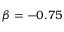<formula> <loc_0><loc_0><loc_500><loc_500>\beta = - 0 . 7 5</formula> 